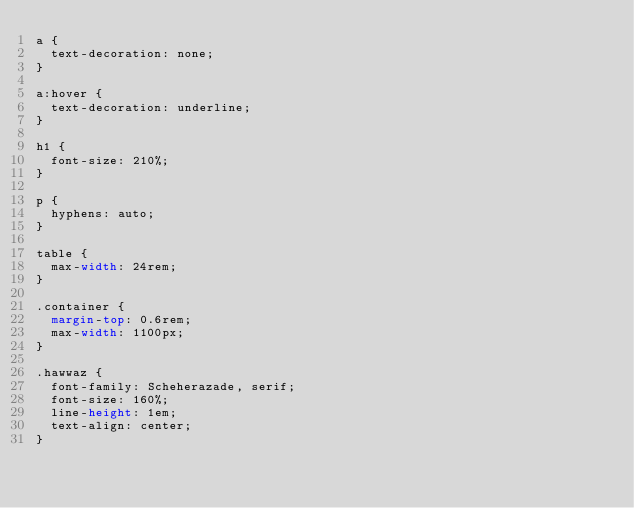<code> <loc_0><loc_0><loc_500><loc_500><_CSS_>a {
  text-decoration: none;
}

a:hover {
  text-decoration: underline;
}

h1 {
  font-size: 210%;
}

p {
  hyphens: auto;
}

table {
  max-width: 24rem;
}

.container {
  margin-top: 0.6rem;
  max-width: 1100px;
}

.hawwaz {
  font-family: Scheherazade, serif;
  font-size: 160%;
  line-height: 1em;
  text-align: center;
}
</code> 